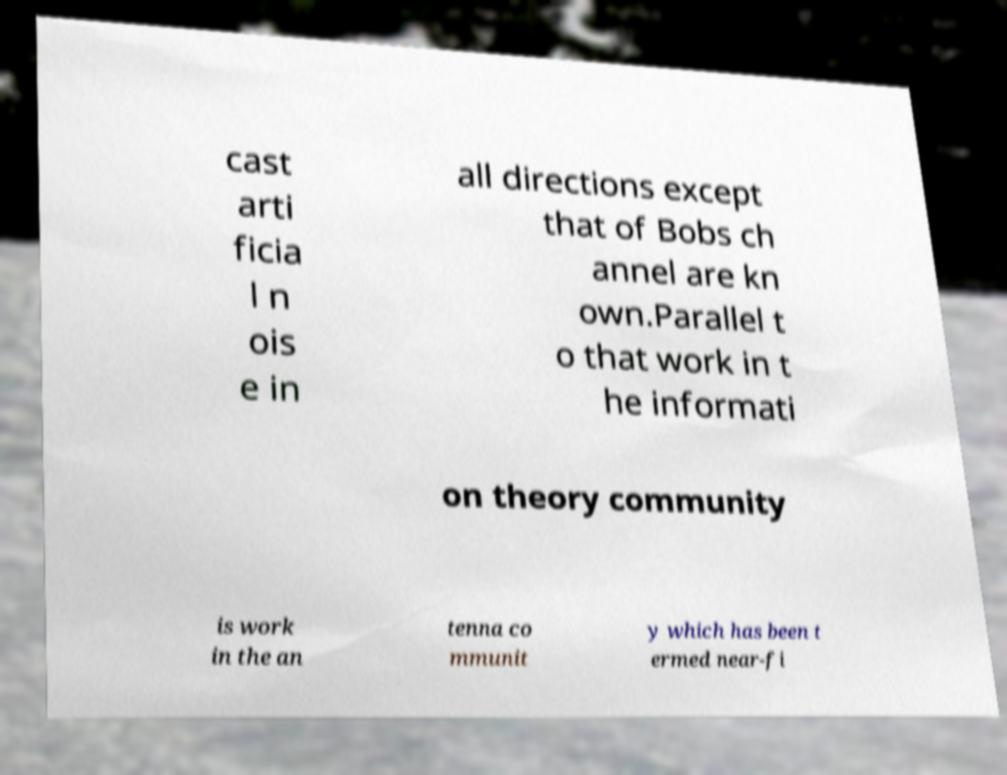Could you assist in decoding the text presented in this image and type it out clearly? cast arti ficia l n ois e in all directions except that of Bobs ch annel are kn own.Parallel t o that work in t he informati on theory community is work in the an tenna co mmunit y which has been t ermed near-fi 